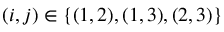Convert formula to latex. <formula><loc_0><loc_0><loc_500><loc_500>( i , j ) \in \{ ( 1 , 2 ) , ( 1 , 3 ) , ( 2 , 3 ) \}</formula> 